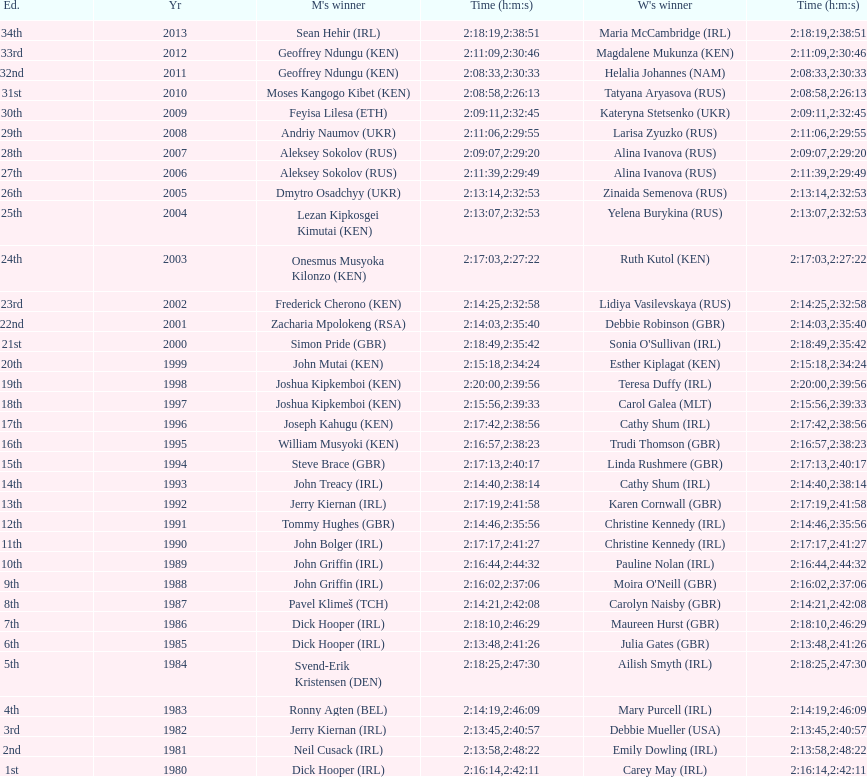Which country is represented for both men and women at the top of the list? Ireland. 